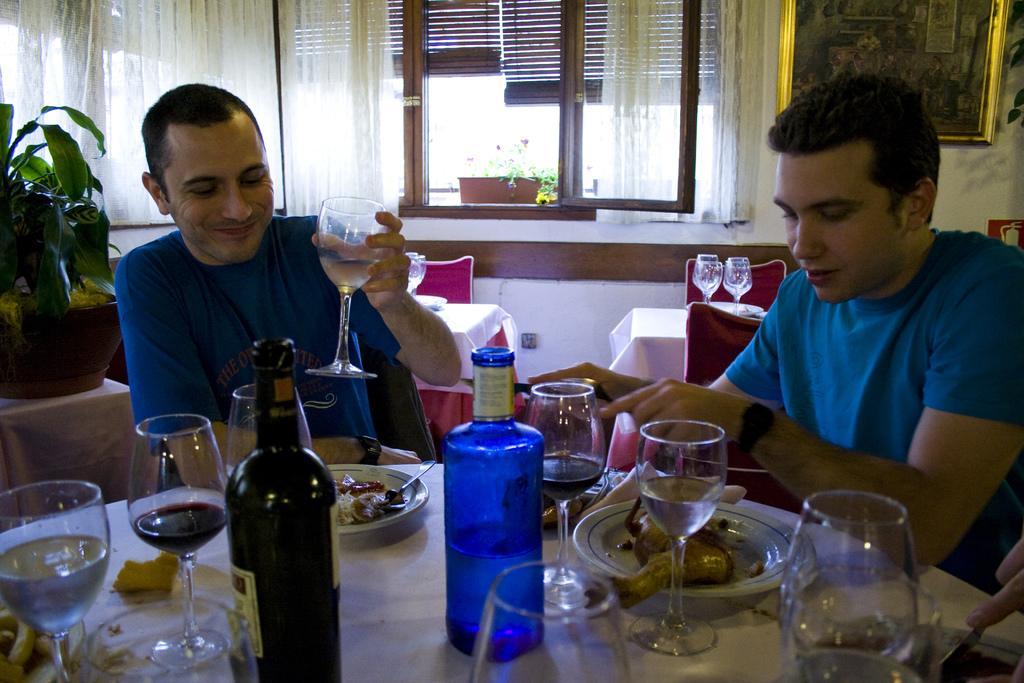Could you give a brief overview of what you see in this image? In this picture we can see two persons are sitting on the chairs. This is table. On the table there are glasses, plates, and bottles. On the background there is a window and this is curtain. And there is a plant. Here we can see a frame on the wall. 